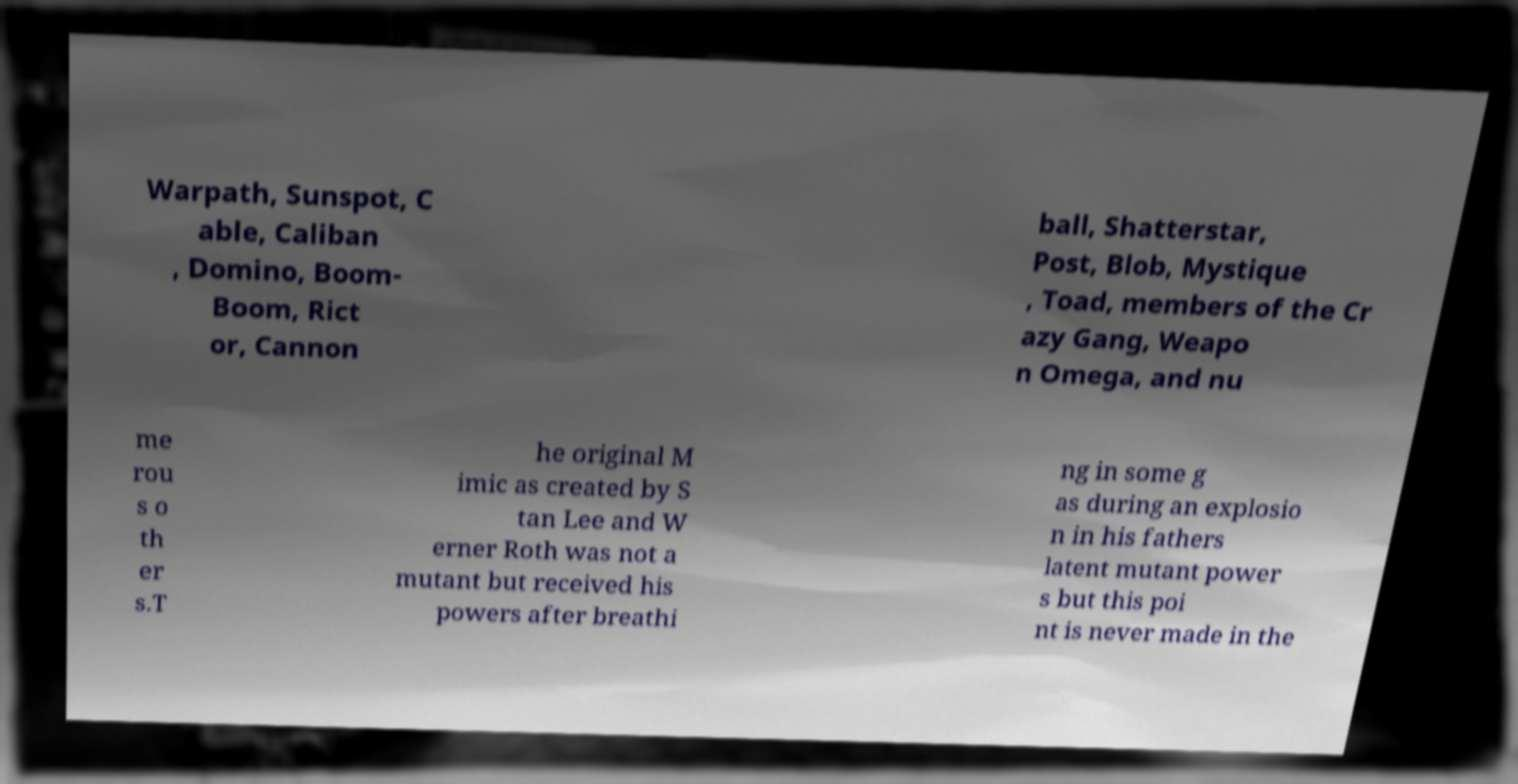I need the written content from this picture converted into text. Can you do that? Warpath, Sunspot, C able, Caliban , Domino, Boom- Boom, Rict or, Cannon ball, Shatterstar, Post, Blob, Mystique , Toad, members of the Cr azy Gang, Weapo n Omega, and nu me rou s o th er s.T he original M imic as created by S tan Lee and W erner Roth was not a mutant but received his powers after breathi ng in some g as during an explosio n in his fathers latent mutant power s but this poi nt is never made in the 